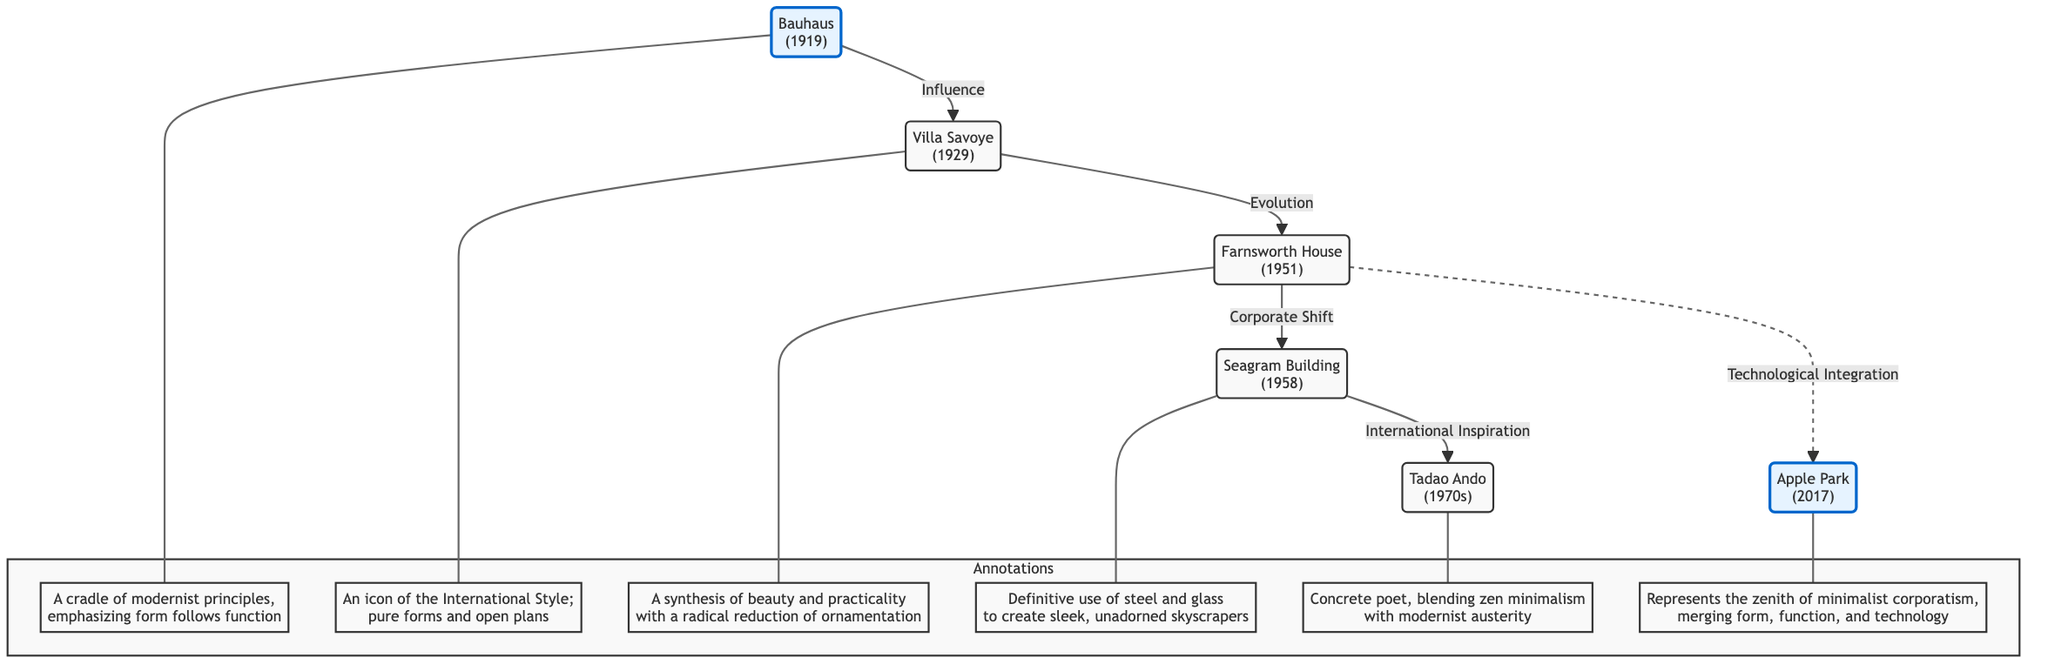What is the earliest building represented in the diagram? The diagram starts with the Bauhaus, which is labeled as being from 1919. By scanning from the top of the diagram, we find that the Bauhaus is the first node listed.
Answer: Bauhaus How many buildings are highlighted in the diagram? There are two buildings highlighted in the diagram: the Bauhaus and Apple Park. Counting the highlighted nodes, we can see these specific buildings marked distinctly compared to the others.
Answer: 2 What architectural style is Villa Savoye associated with? The annotation for Villa Savoye states it is “an icon of the International Style.” This phrase directly describes the architectural style linked with this node in the diagram.
Answer: International Style Which building represents the technological integration that follows the Farnsworth House? The diagram indicates a dashed-line relationship from the Farnsworth House to Apple Park, labeled “Technological Integration.” This shows that Apple Park is associated with this concept following the Farnsworth House.
Answer: Apple Park Which building includes the concept of "form follows function"? The text associated with the Bauhaus states, "emphasizing form follows function." This phrase explicitly connects this principle with the Bauhaus node at the beginning of the diagram.
Answer: Bauhaus What is the key material used in the Seagram Building? The annotation for the Seagram Building mentions the "definitive use of steel and glass." This combination of materials is a crucial aspect of its architectural identity, as noted in the diagram.
Answer: Steel and glass What influence does Bauhaus have on Villa Savoye? The diagram shows a directed edge from the Bauhaus to Villa Savoye, labeled "Influence." This explicitly indicates that Villa Savoye was influenced by the Bauhaus principles.
Answer: Influence Which architectural principle is associated with Tadao Ando? The annotation for Tadao Ando refers to him as a "concrete poet, blending zen minimalism with modernist austerity." This phrase expresses the architectural principle associated with his design philosophy.
Answer: Zen minimalism In which year was the Farnsworth House completed? The completion date listed within the diagram for the Farnsworth House is 1951. This information directly aligns with the node labeled for the building.
Answer: 1951 